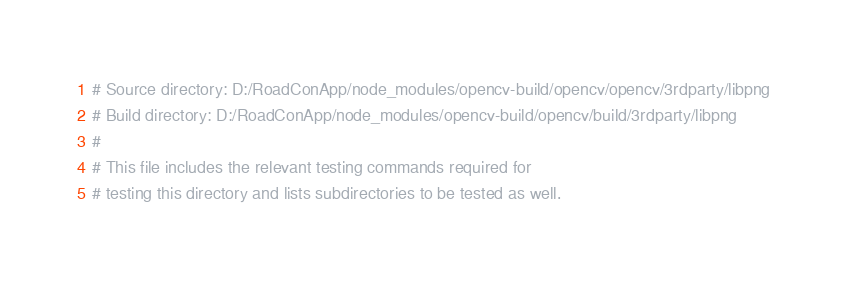<code> <loc_0><loc_0><loc_500><loc_500><_CMake_># Source directory: D:/RoadConApp/node_modules/opencv-build/opencv/opencv/3rdparty/libpng
# Build directory: D:/RoadConApp/node_modules/opencv-build/opencv/build/3rdparty/libpng
# 
# This file includes the relevant testing commands required for 
# testing this directory and lists subdirectories to be tested as well.
</code> 